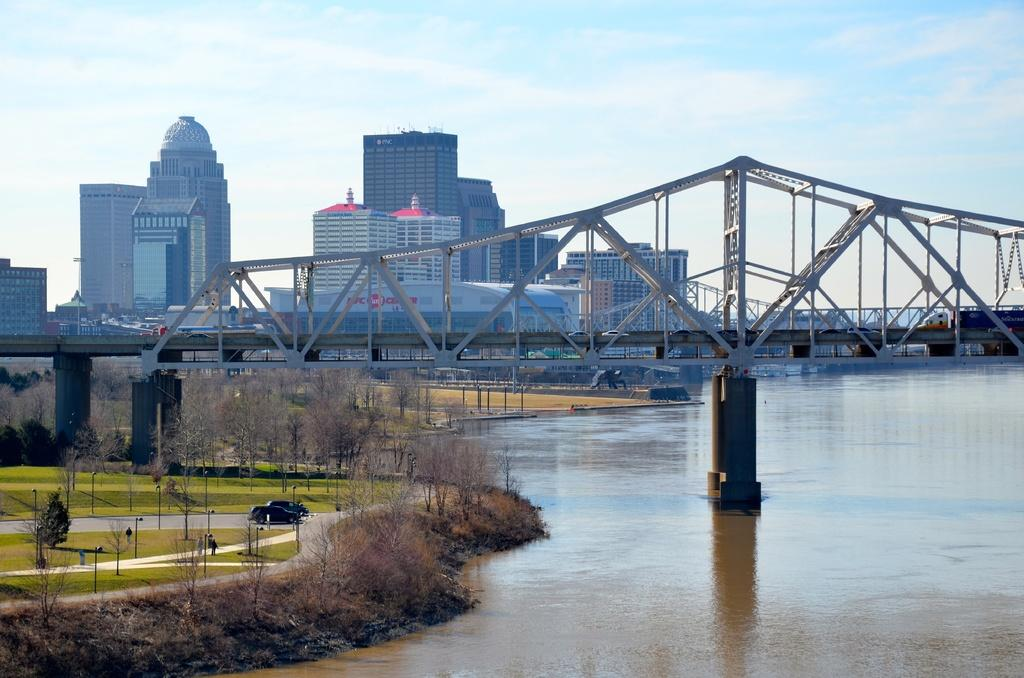What type of structure can be seen in the image? There is a bridge in the image. What natural element is visible in the image? There is water visible in the image. What man-made structures can be seen in the image besides the bridge? There are poles, trees, buildings, and cars on the road visible in the image. What is visible in the background of the image? The sky is visible in the background of the image, and clouds are present in the sky. What type of gate can be seen in the image? There is no gate present in the image. Who is the porter in the image? There is no porter present in the image. 